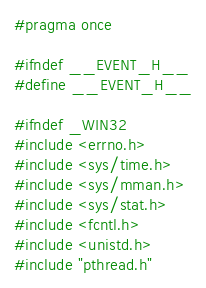<code> <loc_0><loc_0><loc_500><loc_500><_C_>#pragma once

#ifndef __EVENT_H__
#define __EVENT_H__

#ifndef _WIN32
#include <errno.h>
#include <sys/time.h>
#include <sys/mman.h>
#include <sys/stat.h>
#include <fcntl.h>
#include <unistd.h>
#include "pthread.h"
</code> 